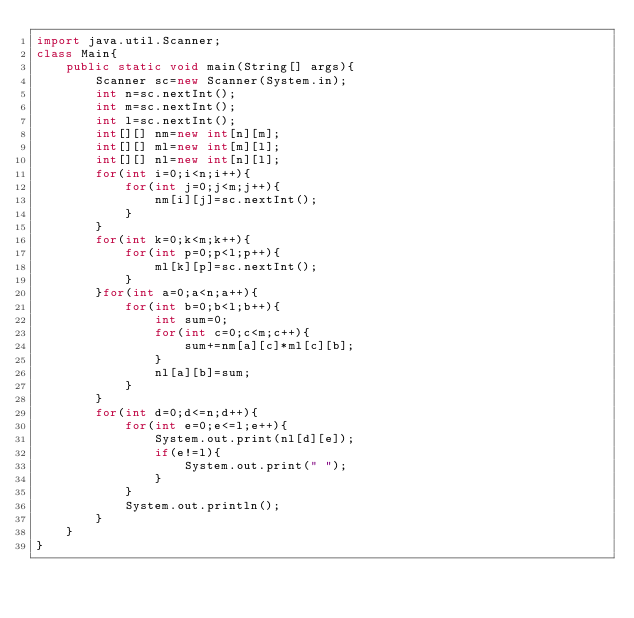Convert code to text. <code><loc_0><loc_0><loc_500><loc_500><_Java_>import java.util.Scanner;
class Main{
    public static void main(String[] args){
        Scanner sc=new Scanner(System.in);
        int n=sc.nextInt();
        int m=sc.nextInt();
        int l=sc.nextInt();
        int[][] nm=new int[n][m];
        int[][] ml=new int[m][l];
        int[][] nl=new int[n][l];
        for(int i=0;i<n;i++){
            for(int j=0;j<m;j++){
                nm[i][j]=sc.nextInt();
            }
        }
        for(int k=0;k<m;k++){
            for(int p=0;p<l;p++){
                ml[k][p]=sc.nextInt();
            }
        }for(int a=0;a<n;a++){
            for(int b=0;b<l;b++){
                int sum=0;
                for(int c=0;c<m;c++){
                    sum+=nm[a][c]*ml[c][b];
                }
                nl[a][b]=sum;
            }
        }
        for(int d=0;d<=n;d++){
            for(int e=0;e<=l;e++){
                System.out.print(nl[d][e]);
                if(e!=l){
                    System.out.print(" ");
                }
            }
            System.out.println();
        }
    }
}
</code> 